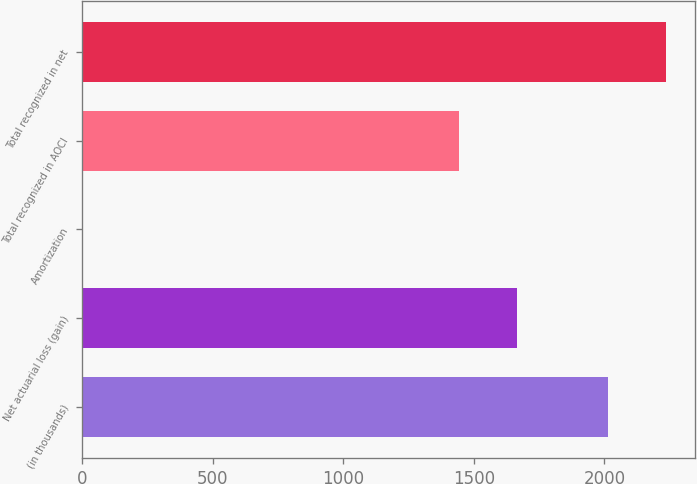Convert chart. <chart><loc_0><loc_0><loc_500><loc_500><bar_chart><fcel>(in thousands)<fcel>Net actuarial loss (gain)<fcel>Amortization<fcel>Total recognized in AOCI<fcel>Total recognized in net<nl><fcel>2014<fcel>1666.3<fcel>1<fcel>1444<fcel>2236.3<nl></chart> 